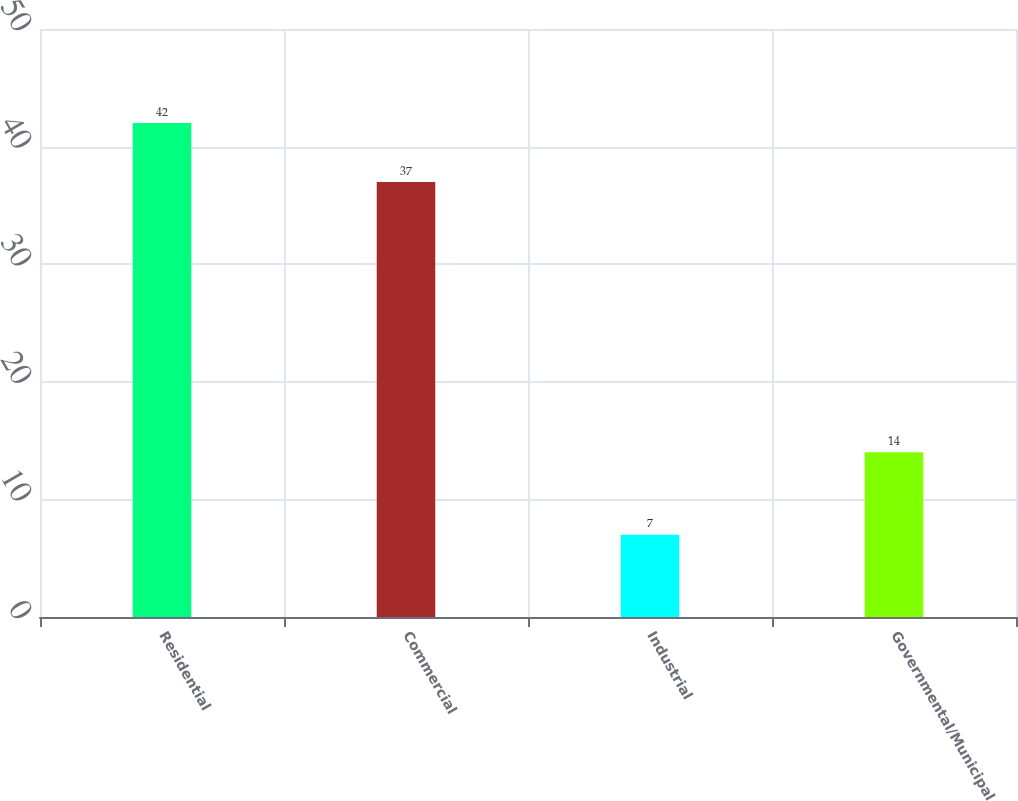<chart> <loc_0><loc_0><loc_500><loc_500><bar_chart><fcel>Residential<fcel>Commercial<fcel>Industrial<fcel>Governmental/Municipal<nl><fcel>42<fcel>37<fcel>7<fcel>14<nl></chart> 